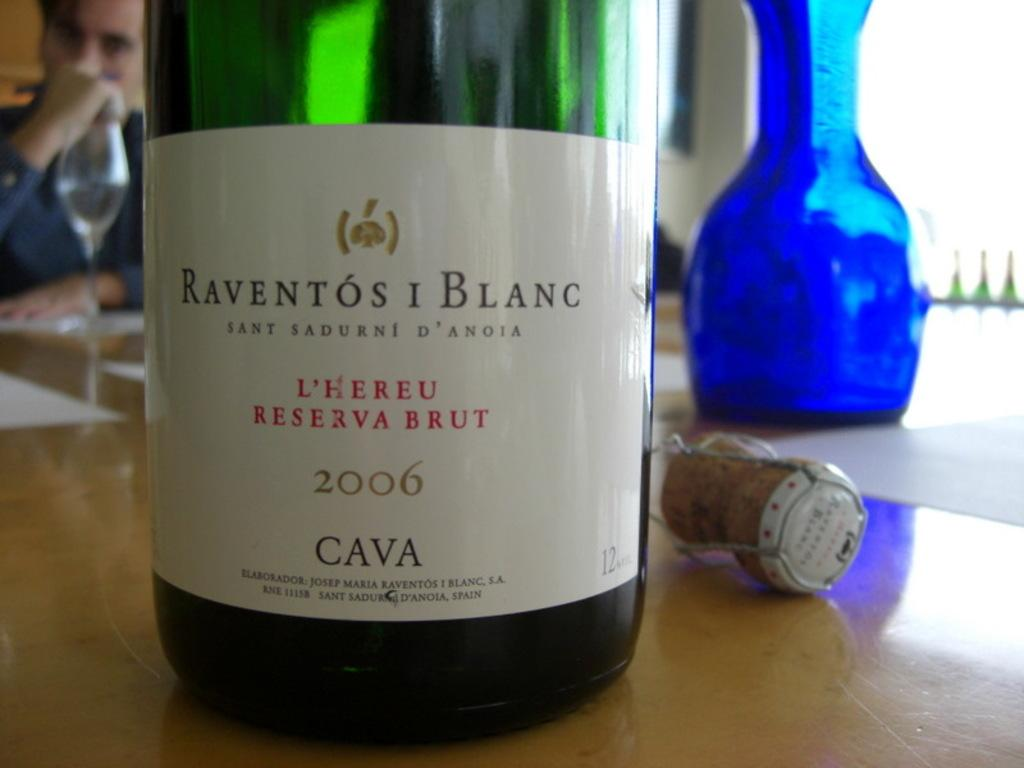What object is on the table in the image? There is a bottle on the table in the image. How much liquid is in the bottle? The bottle is half-filled. What color is the bottle? The bottle is green in color. What color is the label on the bottle? The label on the bottle is white. What other object is on the table? There is a jar on the table. What color is the jar? The jar is blue in color. How is the distribution of the liquid in the bottle being managed in the image? The image does not show any distribution of liquid; it only shows a half-filled green bottle with a white label. 